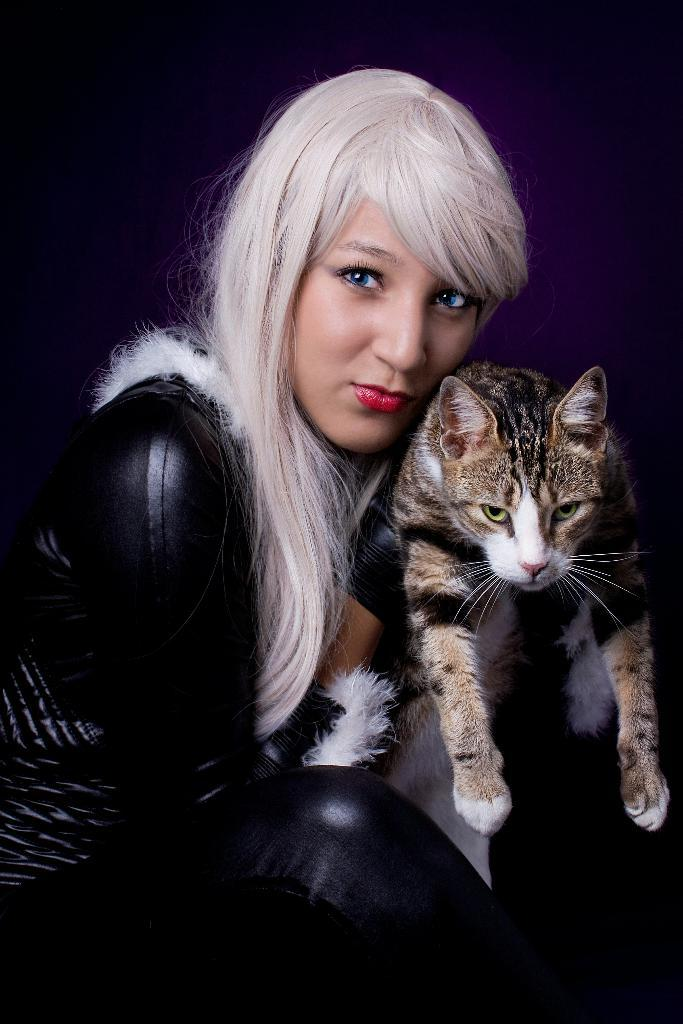Who is the main subject in the image? There is a woman in the image. What is the woman wearing? The woman is wearing a black dress. Can you describe the woman's hair? The woman has white hair. What is the woman holding in her hands? The woman is holding a cat in her hands. What type of drum can be seen in the woman's hands in the image? There is no drum present in the image; the woman is holding a cat in her hands. 